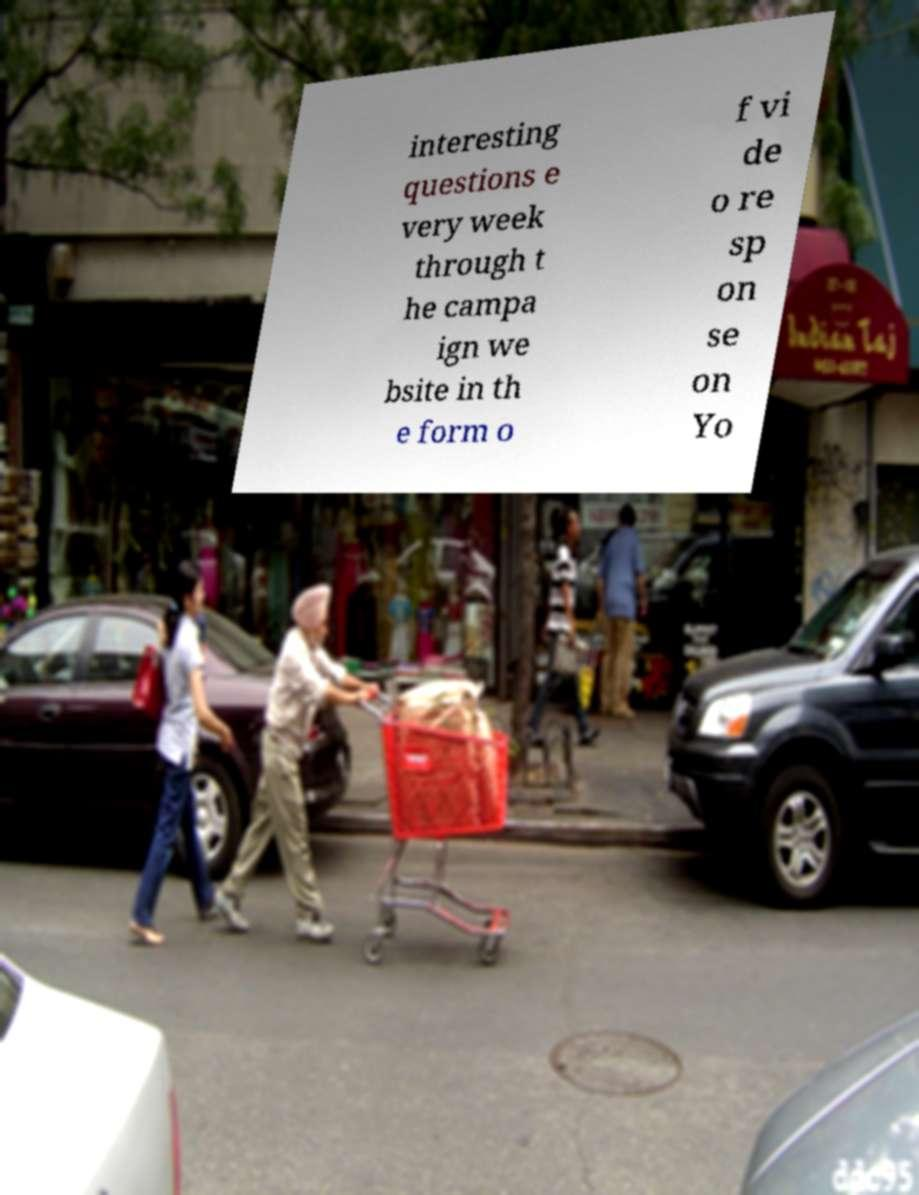Please read and relay the text visible in this image. What does it say? interesting questions e very week through t he campa ign we bsite in th e form o f vi de o re sp on se on Yo 